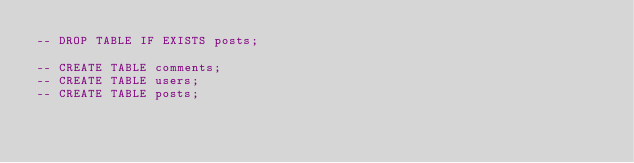<code> <loc_0><loc_0><loc_500><loc_500><_SQL_>-- DROP TABLE IF EXISTS posts;

-- CREATE TABLE comments;
-- CREATE TABLE users;
-- CREATE TABLE posts;</code> 